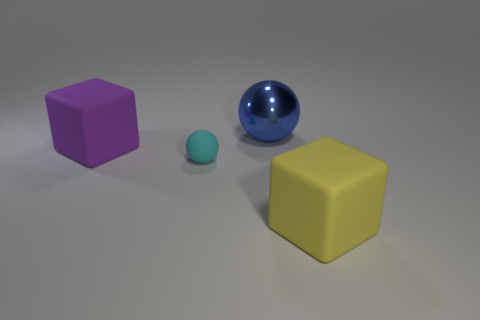Is there any other thing that has the same size as the cyan object?
Provide a succinct answer. No. What is the size of the cube that is on the right side of the large rubber thing to the left of the ball that is behind the big purple rubber cube?
Offer a very short reply. Large. What number of matte objects are big things or gray cylinders?
Offer a terse response. 2. Does the blue thing have the same shape as the big rubber object that is behind the large yellow rubber object?
Your answer should be very brief. No. Is the number of big matte blocks in front of the large purple cube greater than the number of big purple matte blocks that are to the right of the small rubber sphere?
Make the answer very short. Yes. Is there anything else that is the same color as the small rubber sphere?
Keep it short and to the point. No. There is a matte cube that is on the left side of the rubber cube in front of the tiny object; is there a large blue ball that is right of it?
Keep it short and to the point. Yes. There is a large metal object behind the purple cube; is its shape the same as the purple object?
Your answer should be compact. No. Is the number of tiny cyan balls that are behind the big purple matte block less than the number of large rubber blocks on the left side of the cyan rubber thing?
Make the answer very short. Yes. What is the cyan ball made of?
Provide a short and direct response. Rubber. 